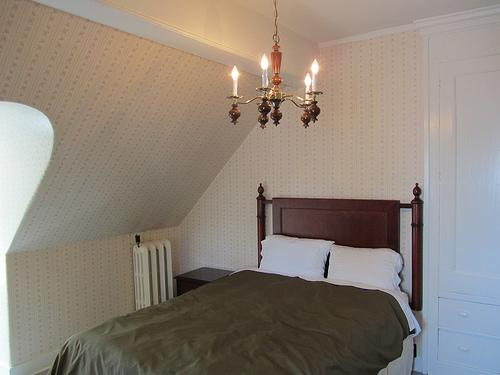How many pillows are on the bed and what color are they? There are two white pillows on the bed. Describe the pattern and color of the wallpaper in the room. The wallpaper has a pastel-colored pattern. What type of storage is featured beside the bed in the image? White pullout storage drawers are featured beside the bed. Give details on the lighting elements seen in the image. The image shows a chandelier hanging from the ceiling with four lightbulbs emitting light, brightening the room. How many lightbulbs are there in the chandelier, and is it turned on? There are four lightbulbs in the chandelier, and it is turned on. State the color of the wall and the ceiling in the image. Both the wall and ceiling are white in color. Identify the color and material of the headboard, nightstand, and bedsheet. The headboard is brown and made of wood, the nightstand is brown and wooden, and the bedsheet is green. Provide a concise description of the bedroom scene in the image. The bedroom features a bed with a brown headboard, white pillows, and a green blanket, along with a hanging chandelier above it, a white radiator, and a nightstand beside it. What type of heater can be seen in the bedroom? A white radiator against the wall can be seen in the bedroom. How is the chandelier attached to the ceiling in the image? The chandelier is attached to the ceiling by a chain. What type of object is hanging over the bed? Chandelier Is there an event happening in the room? No event is detected Is there an orange lightbulb underneath the chandelier? The lightbulbs are described as being on the chandelier, but there is no mention of any orange lightbulb underneath it. Create an animated video depicting the bedroom scene. Cannot create an animated video in text format Did you notice the blue blanket on the floor next to the bed? The blanket in the image is described as green and on the bed, not blue or on the floor. What is the function of the white radiator in the picture? Heating the room Which object in the image is located next to the bed and has a brown color? Dark nightstand Is the pink chandelier hanging directly on the bed? The chandelier is described as hanging over the bed, but there is no mention of its color being pink. How many lightbulbs can you see on the chandelier? Four Explain the arrangement of furniture in the bedroom. There is a bed with a brown headboard, chandelier above, dark nightstand next to bed, white radiator against the wall, and storage drawers Can you see the black radiator hanging from the ceiling? The radiator is described as white and against the wall, not black or hanging from the ceiling. Describe the layout of the bedroom in the image. A double bed with brown headboard and green blanket, chandelier hanging overhead, nightstand and radiator nearby Describe the expressions of the people present in the bedroom. There are no people in the bedroom What color is the blanket on the bed? Green Is there a large red nightstand attached to the headboard of the bed? The nightstand is described as dark and next to the bed, not large, red, or attached to the headboard. Can you spot any text or writings in the image? No text or writings detected Describe the appearance of the chandelier hanging above the bed. The chandelier has four lightbulbs, a chain connected to the ceiling, and it is turned on Create a 3D model of the bedroom based on the image. Cannot provide a 3D model in text format Is there any special event taking place in the bedroom? No special event detected Are the two purple pillows floating above the bed? The pillows are mentioned as being white and on the bed, but not floating or purple in color. Describe the chandelier in the picture, including its size and position. The chandelier is hanging over the bed, it has four lightbulbs and a chain connecting to the ceiling What is the primary activity occurring in this room? Resting or sleeping Describe the pillows on the bed. There are two white pillows on the bed Identify the text on the white radiator against the wall. There is no text on the radiator Is the chandelier in the room turned on or off? Turned on 